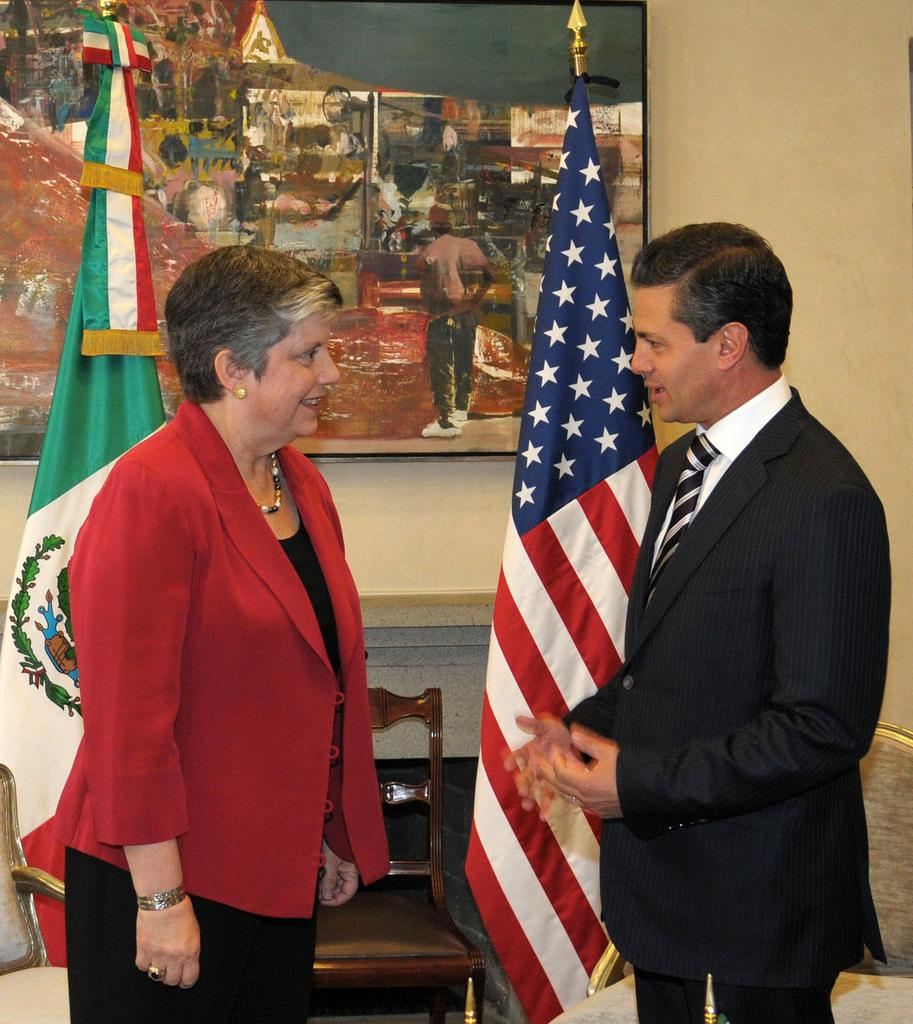How many people are in the image? There are two people standing in the center of the image. What can be seen in the background of the image? There is a wall in the background of the image. Can you describe any objects in the image? There is a photo frame and a chair in the image. What else is present in the image? There are flags in the image. How many worms can be seen crawling on the chair in the image? There are no worms present in the image; the chair is not shown to have any worms on it. 